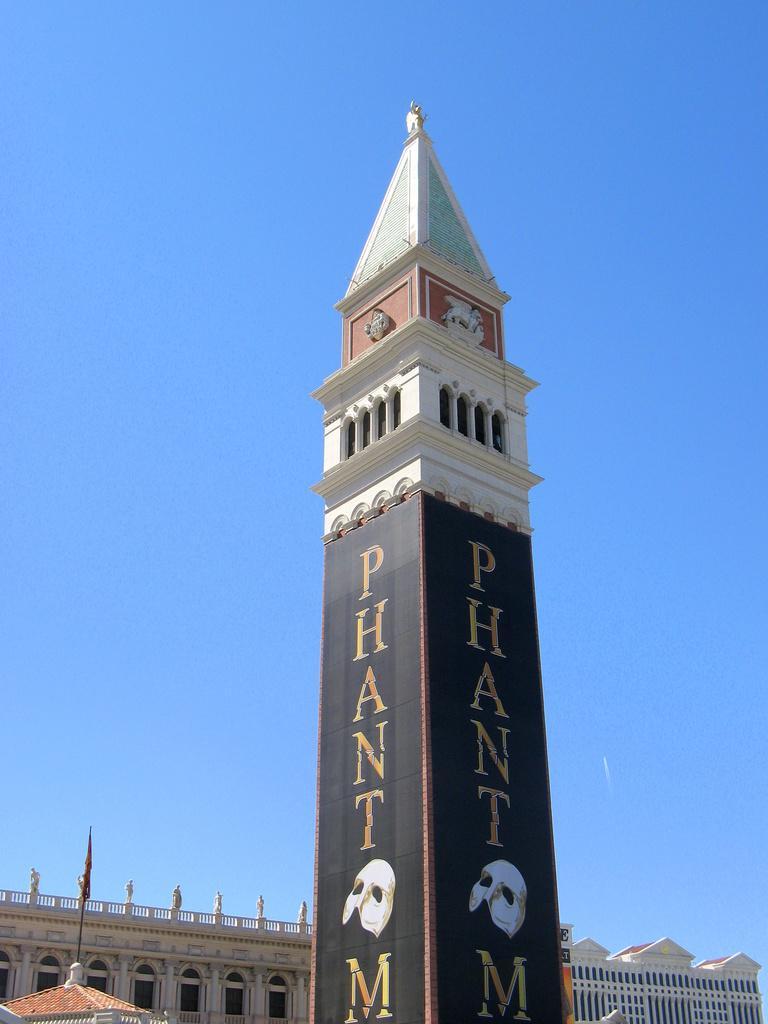Could you give a brief overview of what you see in this image? In this image, we can see a tower. On the tower, we can see banners. Background we can see the sky. At the bottom of the image, we can see buildings, walls, pillars, railings, statues, pole and flag. 